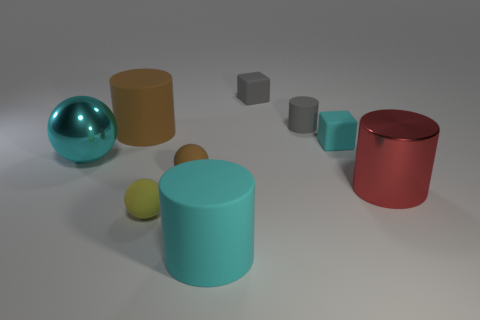Subtract 1 cylinders. How many cylinders are left? 3 Subtract all purple cylinders. Subtract all red spheres. How many cylinders are left? 4 Add 1 yellow things. How many objects exist? 10 Subtract all spheres. How many objects are left? 6 Add 7 big red objects. How many big red objects are left? 8 Add 6 small brown rubber balls. How many small brown rubber balls exist? 7 Subtract 0 purple balls. How many objects are left? 9 Subtract all shiny cylinders. Subtract all big cyan objects. How many objects are left? 6 